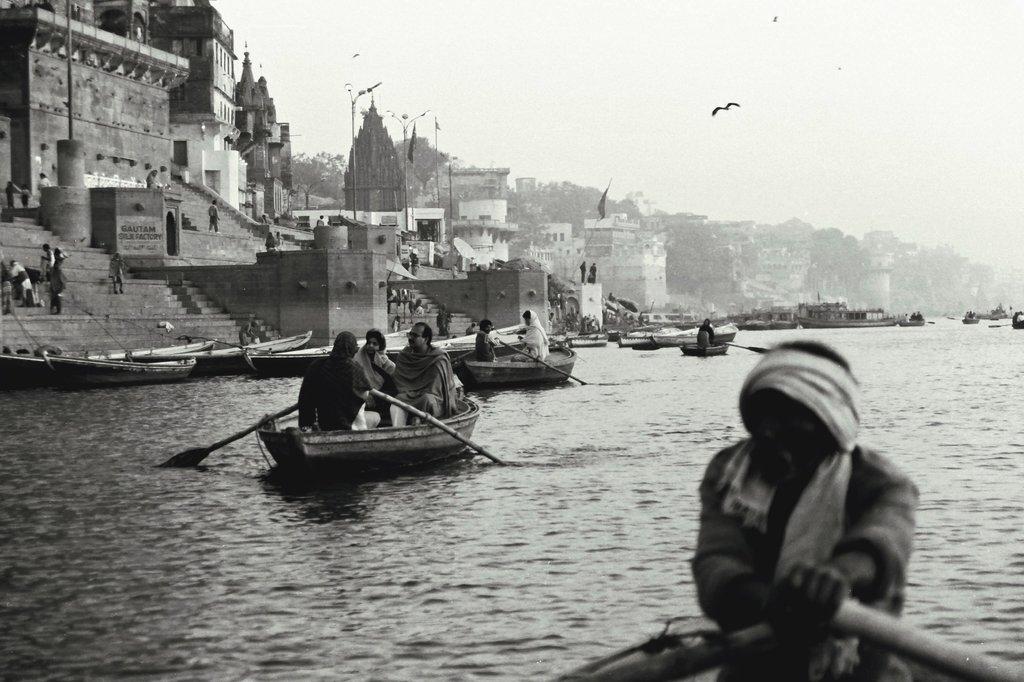Could you give a brief overview of what you see in this image? In this image we can see some group of persons boating on river, on left side of the image there are some persons standing and sitting on stairs and in the background of the image there are some houses, temple, trees and top of the image there is clear sky. 